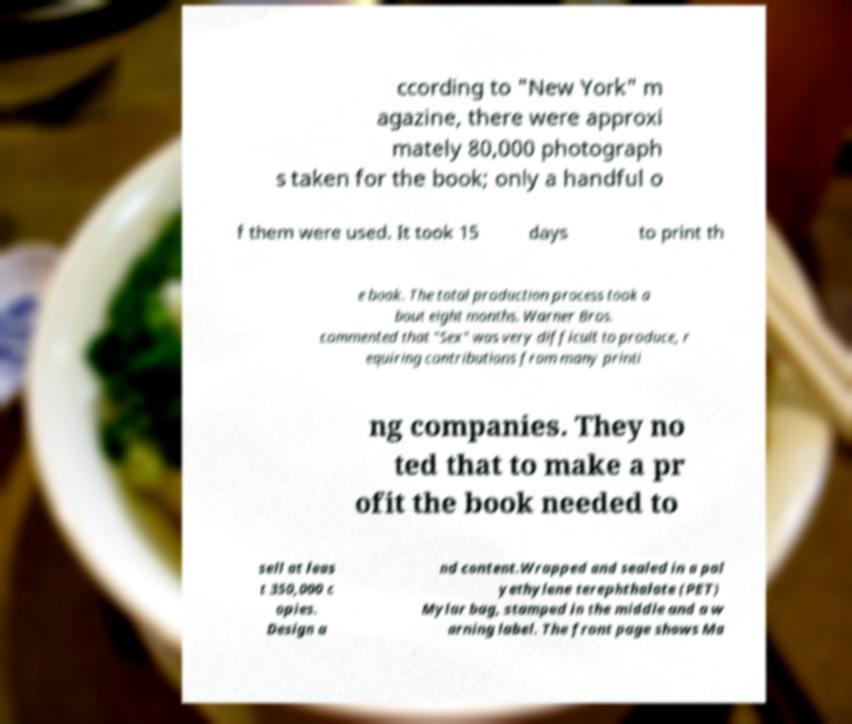What messages or text are displayed in this image? I need them in a readable, typed format. ccording to "New York" m agazine, there were approxi mately 80,000 photograph s taken for the book; only a handful o f them were used. It took 15 days to print th e book. The total production process took a bout eight months. Warner Bros. commented that "Sex" was very difficult to produce, r equiring contributions from many printi ng companies. They no ted that to make a pr ofit the book needed to sell at leas t 350,000 c opies. Design a nd content.Wrapped and sealed in a pol yethylene terephthalate (PET) Mylar bag, stamped in the middle and a w arning label. The front page shows Ma 